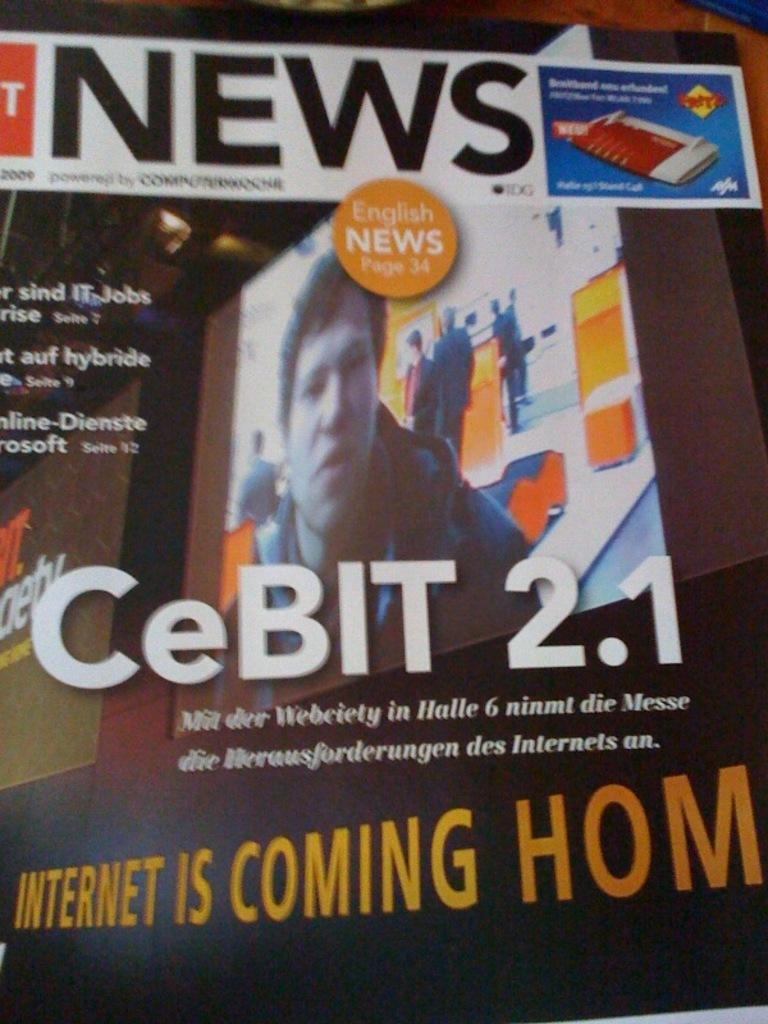<image>
Share a concise interpretation of the image provided. English news is found on page 34 while CeBIT 2.1 has the headline. 